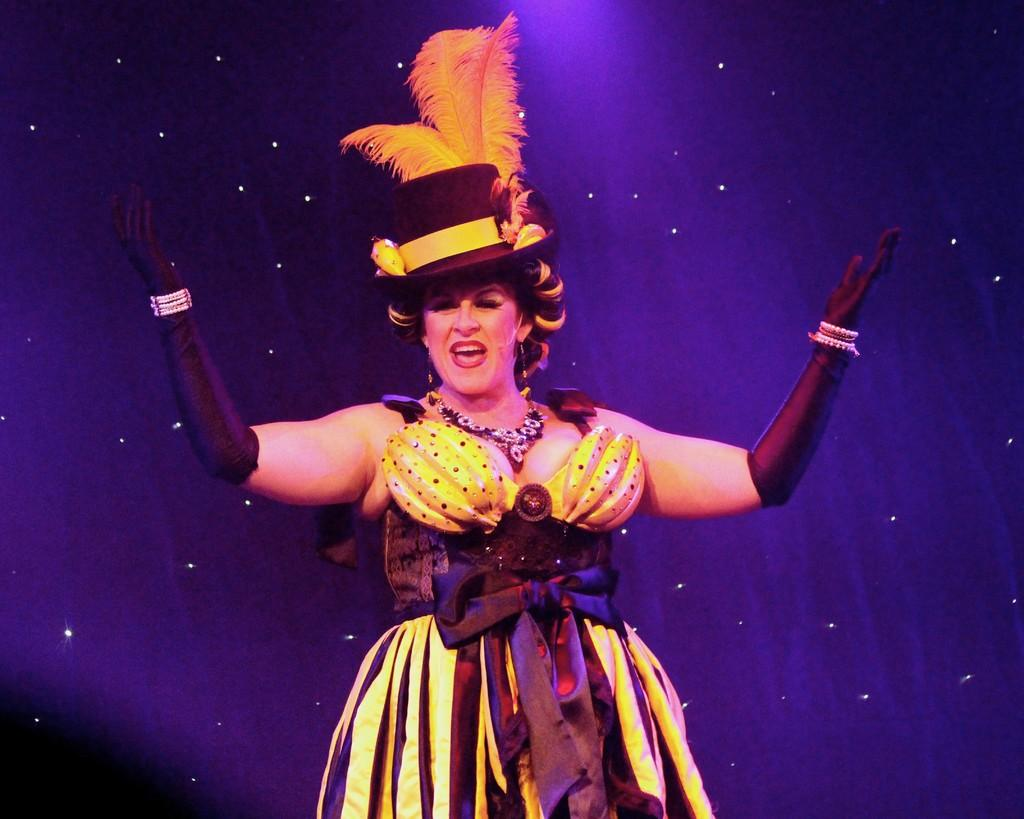Who is present in the image? There is a woman in the image. What is the woman doing in the image? The woman is standing in the image. What expression does the woman have in the image? The woman is smiling in the image. What can be seen in the background of the image? There are lights in the background of the image. What type of paste is being used to attach the screws to the wood in the image? There is no paste, screws, or wood present in the image. 